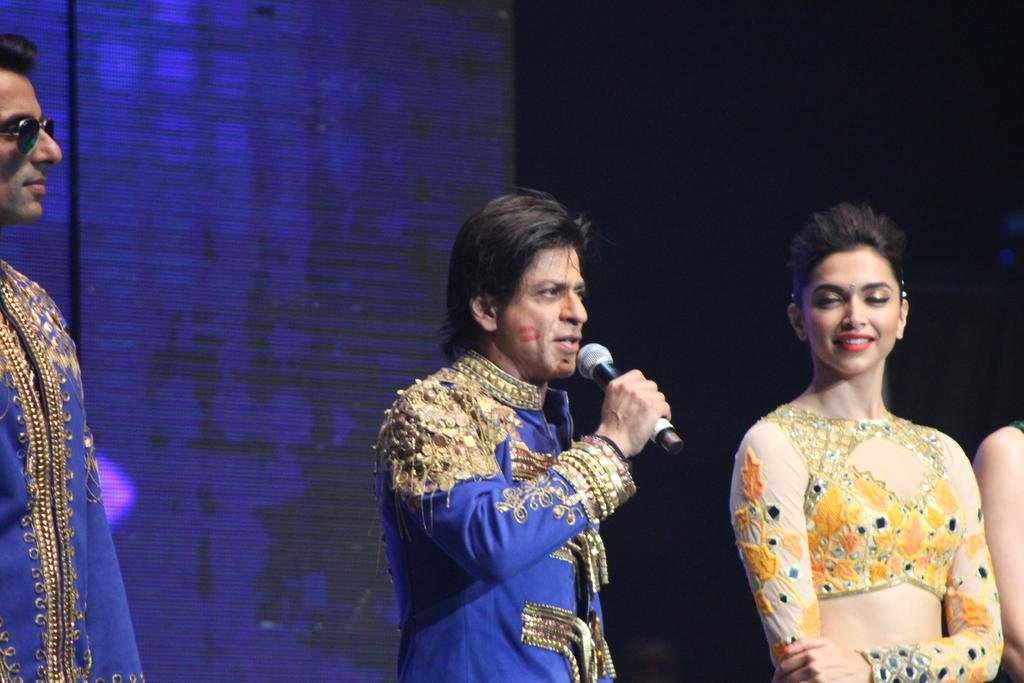Who is the main subject in the image? There is a man in the image. What is the man holding in his hand? The man is holding a mic with his hand. Are there any other people in the image? Yes, there are two people beside the man. What can be observed about the background of the image? The background of the image is dark. What type of governor is visible in the image? There is no governor present in the image. Can you tell me how many times the man changes his position in the image? The man's position does not change in the image; he is holding a mic with his hand. 